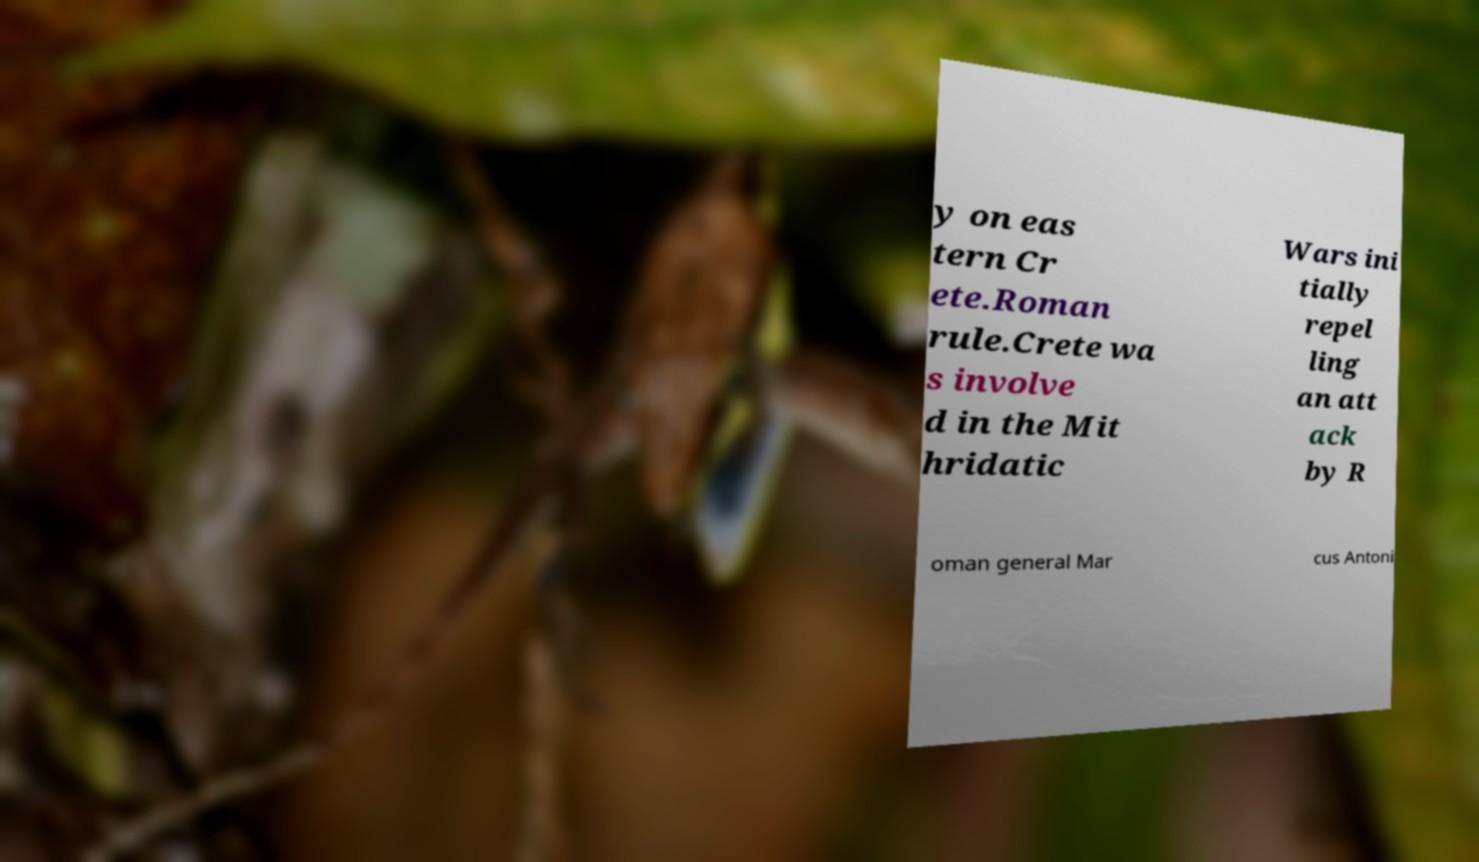For documentation purposes, I need the text within this image transcribed. Could you provide that? y on eas tern Cr ete.Roman rule.Crete wa s involve d in the Mit hridatic Wars ini tially repel ling an att ack by R oman general Mar cus Antoni 